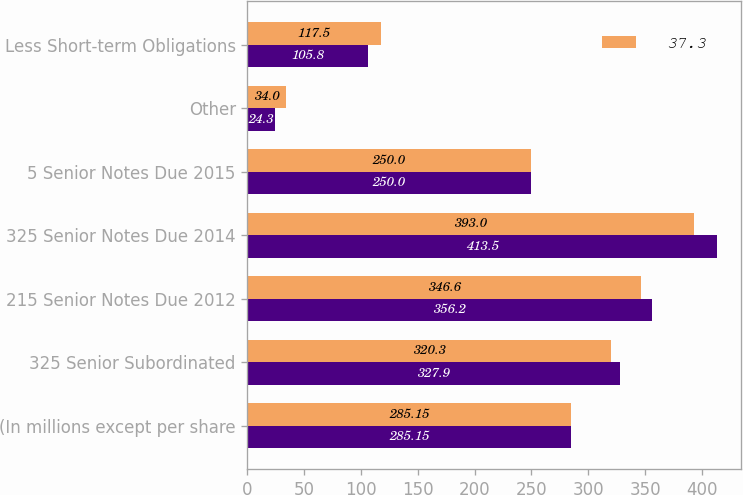Convert chart to OTSL. <chart><loc_0><loc_0><loc_500><loc_500><stacked_bar_chart><ecel><fcel>(In millions except per share<fcel>325 Senior Subordinated<fcel>215 Senior Notes Due 2012<fcel>325 Senior Notes Due 2014<fcel>5 Senior Notes Due 2015<fcel>Other<fcel>Less Short-term Obligations<nl><fcel>nan<fcel>285.15<fcel>327.9<fcel>356.2<fcel>413.5<fcel>250<fcel>24.3<fcel>105.8<nl><fcel>37.3<fcel>285.15<fcel>320.3<fcel>346.6<fcel>393<fcel>250<fcel>34<fcel>117.5<nl></chart> 